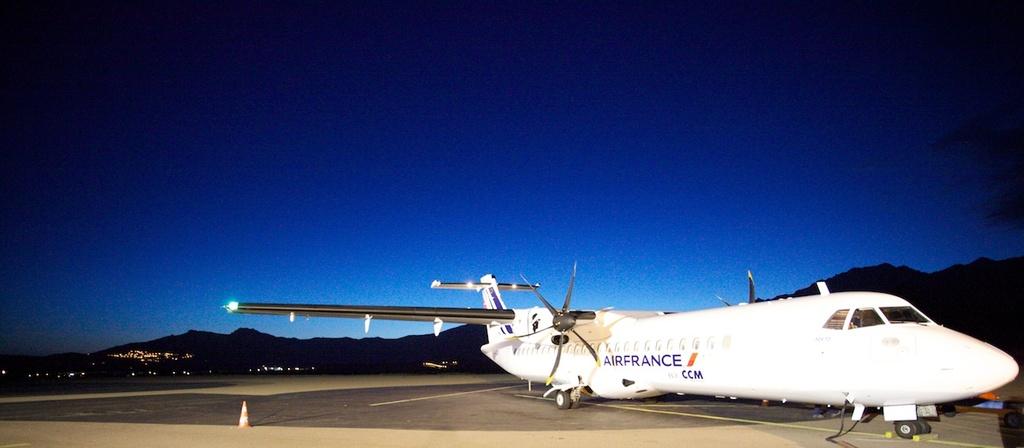What airline is this plane for?
Give a very brief answer. Air france. 